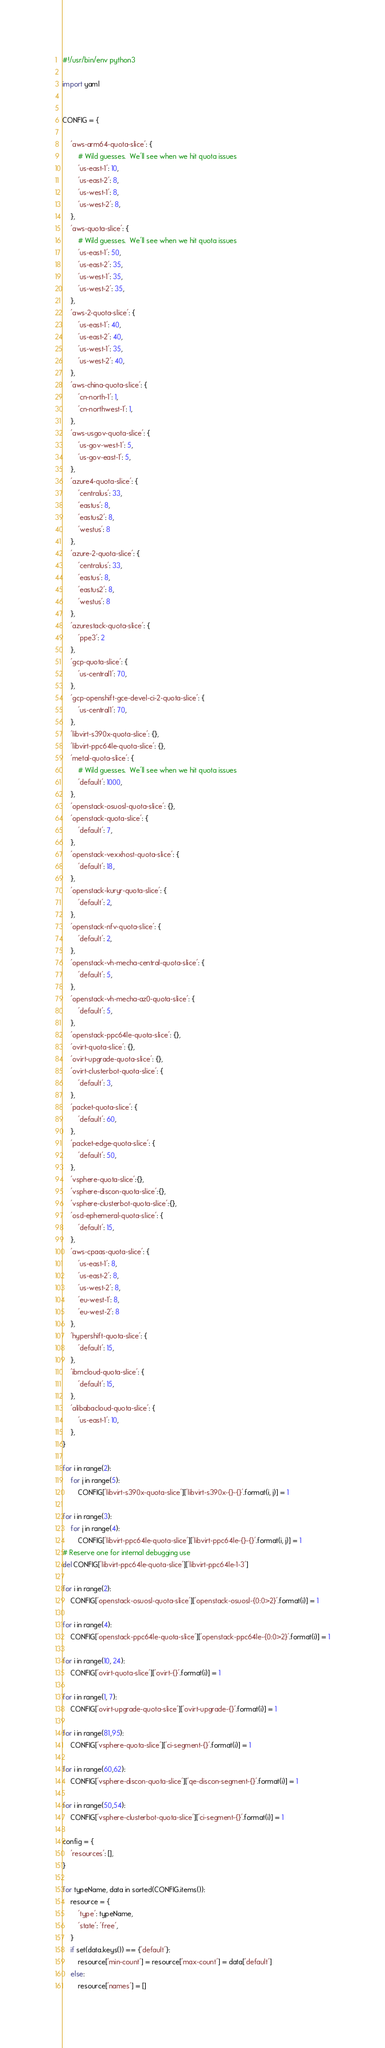Convert code to text. <code><loc_0><loc_0><loc_500><loc_500><_Python_>#!/usr/bin/env python3

import yaml


CONFIG = {

    'aws-arm64-quota-slice': {
        # Wild guesses.  We'll see when we hit quota issues
        'us-east-1': 10,
        'us-east-2': 8,
        'us-west-1': 8,
        'us-west-2': 8,
    },
    'aws-quota-slice': {
        # Wild guesses.  We'll see when we hit quota issues
        'us-east-1': 50,
        'us-east-2': 35,
        'us-west-1': 35,
        'us-west-2': 35,
    },
    'aws-2-quota-slice': {
        'us-east-1': 40,
        'us-east-2': 40,
        'us-west-1': 35,
        'us-west-2': 40,
    },
    'aws-china-quota-slice': {
        'cn-north-1': 1,
        'cn-northwest-1': 1,
    },
    'aws-usgov-quota-slice': {
        'us-gov-west-1': 5,
        'us-gov-east-1': 5,
    },
    'azure4-quota-slice': {
        'centralus': 33,
        'eastus': 8,
        'eastus2': 8,
        'westus': 8
    },
    'azure-2-quota-slice': {
        'centralus': 33,
        'eastus': 8,
        'eastus2': 8,
        'westus': 8
    },
    'azurestack-quota-slice': {
        'ppe3': 2
    },
    'gcp-quota-slice': {
        'us-central1': 70,
    },
    'gcp-openshift-gce-devel-ci-2-quota-slice': {
        'us-central1': 70,
    },
    'libvirt-s390x-quota-slice': {},
    'libvirt-ppc64le-quota-slice': {},
    'metal-quota-slice': {
        # Wild guesses.  We'll see when we hit quota issues
        'default': 1000,
    },
    'openstack-osuosl-quota-slice': {},
    'openstack-quota-slice': {
        'default': 7,
    },
    'openstack-vexxhost-quota-slice': {
        'default': 18,
    },
    'openstack-kuryr-quota-slice': {
        'default': 2,
    },
    'openstack-nfv-quota-slice': {
        'default': 2,
    },
    'openstack-vh-mecha-central-quota-slice': {
        'default': 5,
    },
    'openstack-vh-mecha-az0-quota-slice': {
        'default': 5,
    },
    'openstack-ppc64le-quota-slice': {},
    'ovirt-quota-slice': {},
    'ovirt-upgrade-quota-slice': {},
    'ovirt-clusterbot-quota-slice': {
        'default': 3,
    },
    'packet-quota-slice': {
        'default': 60,
    },
    'packet-edge-quota-slice': {
        'default': 50,
    },
    'vsphere-quota-slice':{},
    'vsphere-discon-quota-slice':{},
    'vsphere-clusterbot-quota-slice':{},
    'osd-ephemeral-quota-slice': {
        'default': 15,
    },
    'aws-cpaas-quota-slice': {
        'us-east-1': 8,
        'us-east-2': 8,
        'us-west-2': 8,
        'eu-west-1': 8,
        'eu-west-2': 8
    },
    'hypershift-quota-slice': {
        'default': 15,
    },
    'ibmcloud-quota-slice': {
        'default': 15,
    },
    'alibabacloud-quota-slice': {
        'us-east-1': 10,
    },
}

for i in range(2):
    for j in range(5):
        CONFIG['libvirt-s390x-quota-slice']['libvirt-s390x-{}-{}'.format(i, j)] = 1

for i in range(3):
    for j in range(4):
        CONFIG['libvirt-ppc64le-quota-slice']['libvirt-ppc64le-{}-{}'.format(i, j)] = 1
# Reserve one for internal debugging use
del CONFIG['libvirt-ppc64le-quota-slice']['libvirt-ppc64le-1-3']

for i in range(2):
    CONFIG['openstack-osuosl-quota-slice']['openstack-osuosl-{0:0>2}'.format(i)] = 1

for i in range(4):
    CONFIG['openstack-ppc64le-quota-slice']['openstack-ppc64le-{0:0>2}'.format(i)] = 1

for i in range(10, 24):
    CONFIG['ovirt-quota-slice']['ovirt-{}'.format(i)] = 1

for i in range(1, 7):
    CONFIG['ovirt-upgrade-quota-slice']['ovirt-upgrade-{}'.format(i)] = 1

for i in range(81,95):
    CONFIG['vsphere-quota-slice']['ci-segment-{}'.format(i)] = 1

for i in range(60,62):
    CONFIG['vsphere-discon-quota-slice']['qe-discon-segment-{}'.format(i)] = 1

for i in range(50,54):
    CONFIG['vsphere-clusterbot-quota-slice']['ci-segment-{}'.format(i)] = 1

config = {
    'resources': [],
}

for typeName, data in sorted(CONFIG.items()):
    resource = {
        'type': typeName,
        'state': 'free',
    }
    if set(data.keys()) == {'default'}:
        resource['min-count'] = resource['max-count'] = data['default']
    else:
        resource['names'] = []</code> 